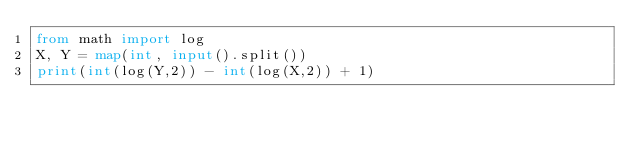Convert code to text. <code><loc_0><loc_0><loc_500><loc_500><_Python_>from math import log
X, Y = map(int, input().split())
print(int(log(Y,2)) - int(log(X,2)) + 1)</code> 